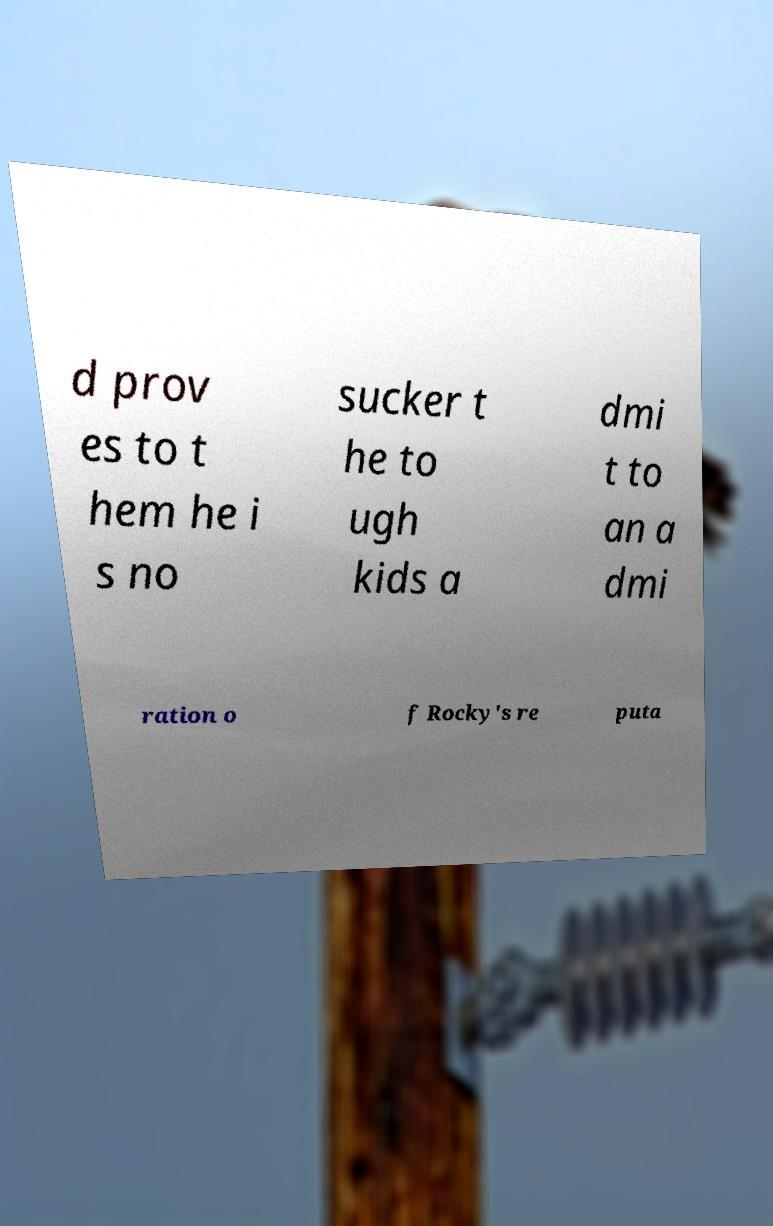Could you extract and type out the text from this image? d prov es to t hem he i s no sucker t he to ugh kids a dmi t to an a dmi ration o f Rocky's re puta 